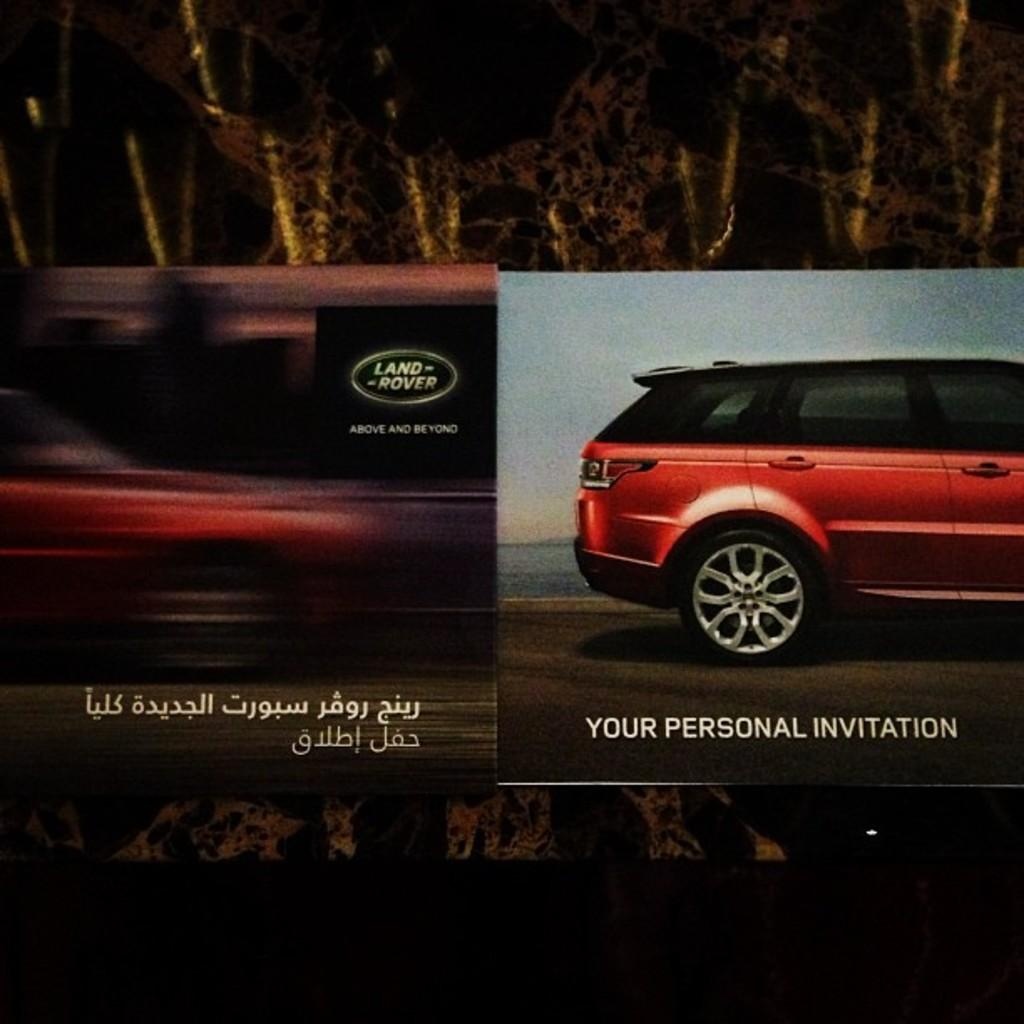What is the main subject of the image? There is an advertisement in the image. What else can be seen in the image besides the advertisement? There is a car and a road in the image. Is there any text present in the image? Yes, there is text in the image. How many girls are balancing on the chickens in the image? There are no girls or chickens present in the image. 